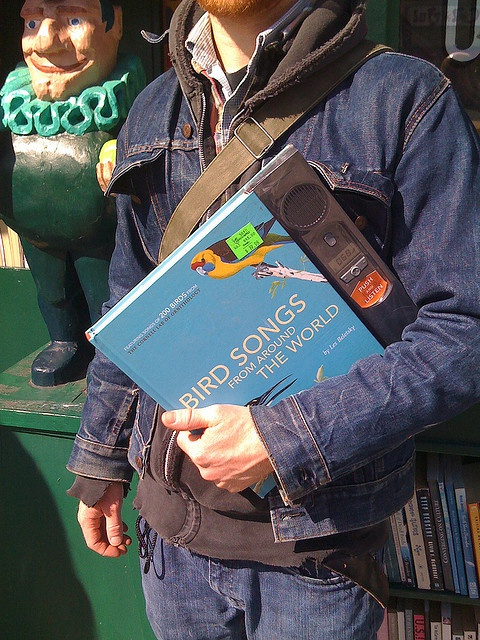Describe the objects in this image and their specific colors. I can see people in black and gray tones, book in black, gray, and lightblue tones, book in black, gray, navy, and blue tones, backpack in black, tan, and gray tones, and book in black, gray, blue, and navy tones in this image. 